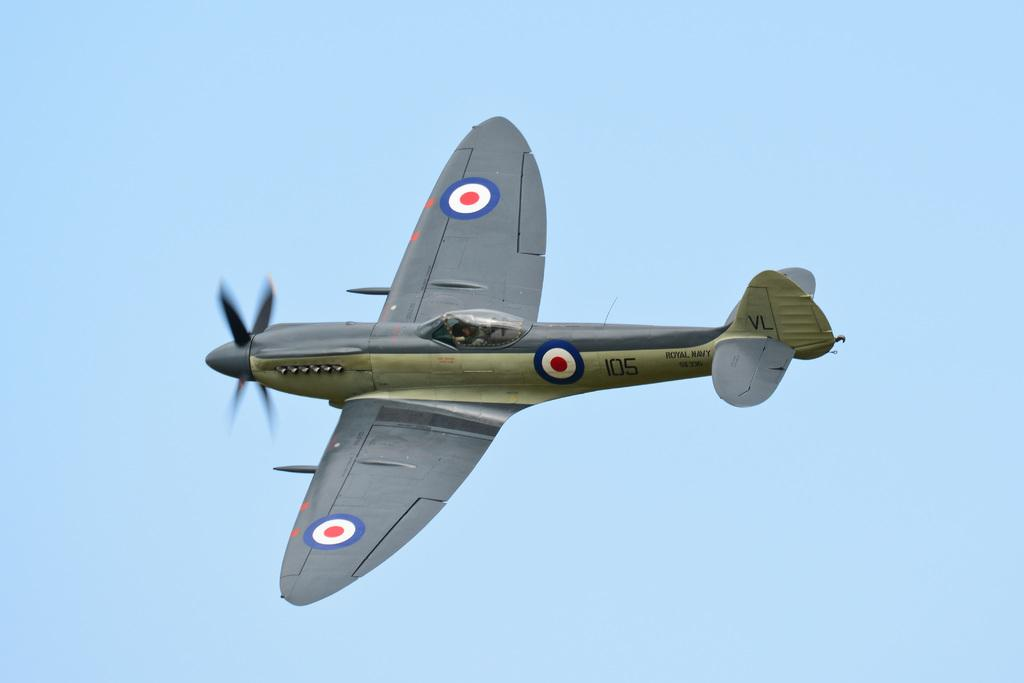What is the main subject of the image? The main subject of the image is an airplane. What is the airplane doing in the image? The airplane is flying in the sky. What type of popcorn is being served on the airplane in the image? There is no popcorn present in the image; it only features an airplane flying in the sky. Is there any smoke coming out of the airplane in the image? There is no smoke visible in the image; the airplane is simply flying in the sky. 